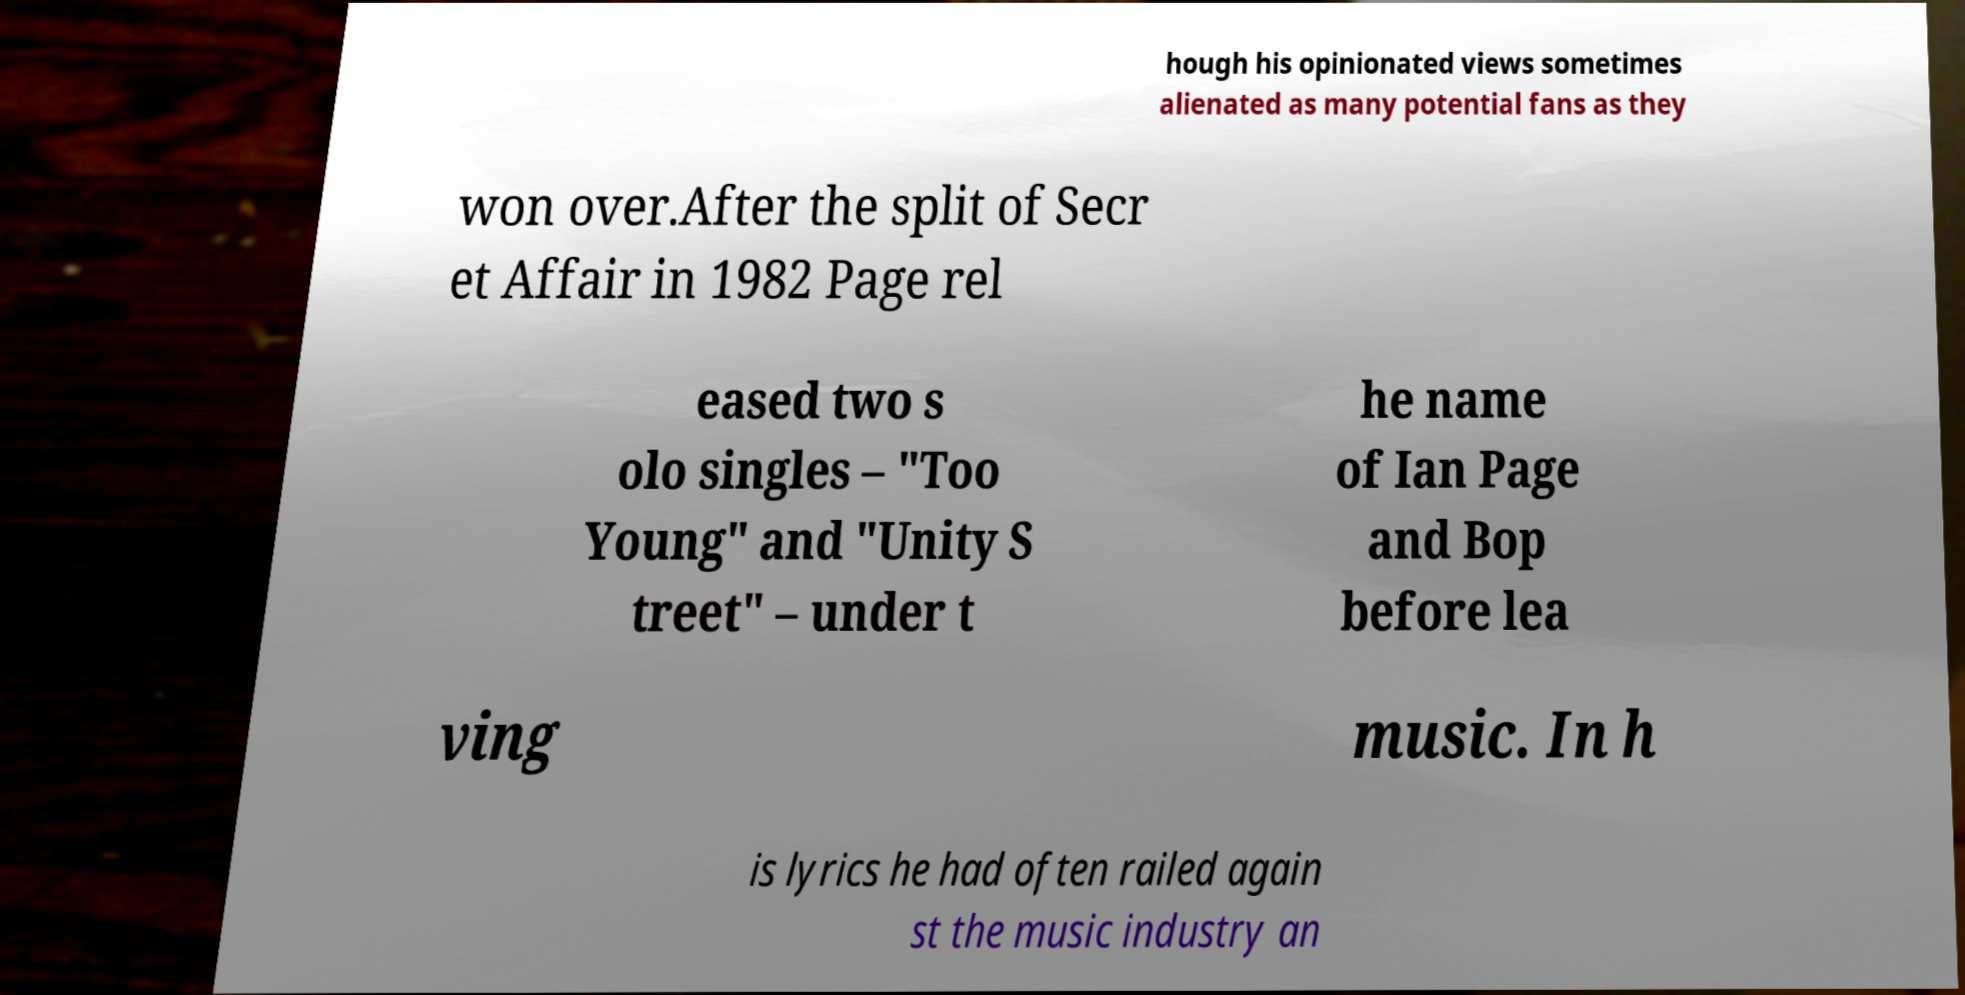I need the written content from this picture converted into text. Can you do that? hough his opinionated views sometimes alienated as many potential fans as they won over.After the split of Secr et Affair in 1982 Page rel eased two s olo singles – "Too Young" and "Unity S treet" – under t he name of Ian Page and Bop before lea ving music. In h is lyrics he had often railed again st the music industry an 